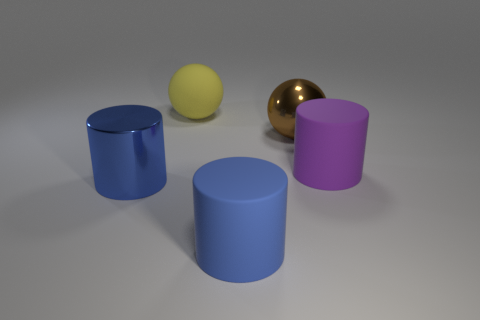Subtract all blue cylinders. How many cylinders are left? 1 Add 5 spheres. How many objects exist? 10 Subtract all purple cylinders. How many cylinders are left? 2 Add 1 large purple cylinders. How many large purple cylinders are left? 2 Add 4 blue cylinders. How many blue cylinders exist? 6 Subtract 0 blue spheres. How many objects are left? 5 Subtract all cylinders. How many objects are left? 2 Subtract 2 cylinders. How many cylinders are left? 1 Subtract all blue cylinders. Subtract all gray spheres. How many cylinders are left? 1 Subtract all cyan balls. How many yellow cylinders are left? 0 